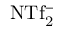<formula> <loc_0><loc_0><loc_500><loc_500>N T f _ { 2 } ^ { - }</formula> 